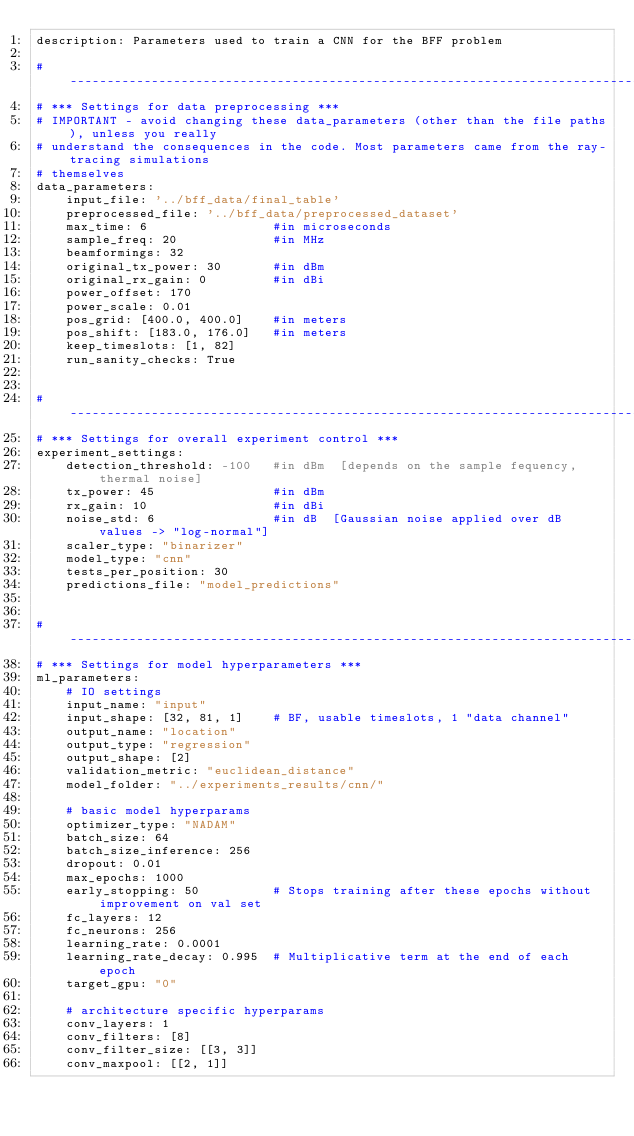<code> <loc_0><loc_0><loc_500><loc_500><_YAML_>description: Parameters used to train a CNN for the BFF problem

# -------------------------------------------------------------------------------------------------
# *** Settings for data preprocessing ***
# IMPORTANT - avoid changing these data_parameters (other than the file paths), unless you really
# understand the consequences in the code. Most parameters came from the ray-tracing simulations
# themselves
data_parameters:
    input_file: '../bff_data/final_table'
    preprocessed_file: '../bff_data/preprocessed_dataset'
    max_time: 6                 #in microseconds
    sample_freq: 20             #in MHz
    beamformings: 32
    original_tx_power: 30       #in dBm
    original_rx_gain: 0         #in dBi
    power_offset: 170
    power_scale: 0.01
    pos_grid: [400.0, 400.0]    #in meters
    pos_shift: [183.0, 176.0]   #in meters
    keep_timeslots: [1, 82]
    run_sanity_checks: True


# -------------------------------------------------------------------------------------------------
# *** Settings for overall experiment control ***
experiment_settings:
    detection_threshold: -100   #in dBm  [depends on the sample fequency, thermal noise]
    tx_power: 45                #in dBm
    rx_gain: 10                 #in dBi
    noise_std: 6                #in dB  [Gaussian noise applied over dB values -> "log-normal"]
    scaler_type: "binarizer"
    model_type: "cnn"
    tests_per_position: 30
    predictions_file: "model_predictions"


# -------------------------------------------------------------------------------------------------
# *** Settings for model hyperparameters ***
ml_parameters:
    # IO settings
    input_name: "input"
    input_shape: [32, 81, 1]    # BF, usable timeslots, 1 "data channel"
    output_name: "location"
    output_type: "regression"
    output_shape: [2]
    validation_metric: "euclidean_distance"
    model_folder: "../experiments_results/cnn/"

    # basic model hyperparams
    optimizer_type: "NADAM"
    batch_size: 64
    batch_size_inference: 256
    dropout: 0.01
    max_epochs: 1000
    early_stopping: 50          # Stops training after these epochs without improvement on val set
    fc_layers: 12
    fc_neurons: 256
    learning_rate: 0.0001
    learning_rate_decay: 0.995  # Multiplicative term at the end of each epoch
    target_gpu: "0"

    # architecture specific hyperparams
    conv_layers: 1
    conv_filters: [8]
    conv_filter_size: [[3, 3]]
    conv_maxpool: [[2, 1]]
</code> 